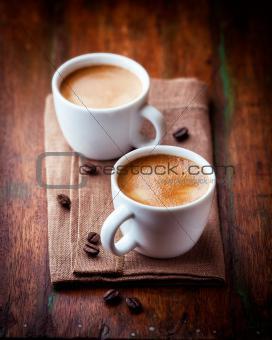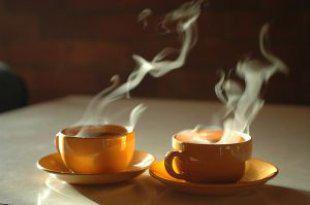The first image is the image on the left, the second image is the image on the right. For the images displayed, is the sentence "The pair of cups in the right image have no handles." factually correct? Answer yes or no. No. The first image is the image on the left, the second image is the image on the right. Analyze the images presented: Is the assertion "There are four cups of hot drinks, and two of them are sitting on plates." valid? Answer yes or no. Yes. 